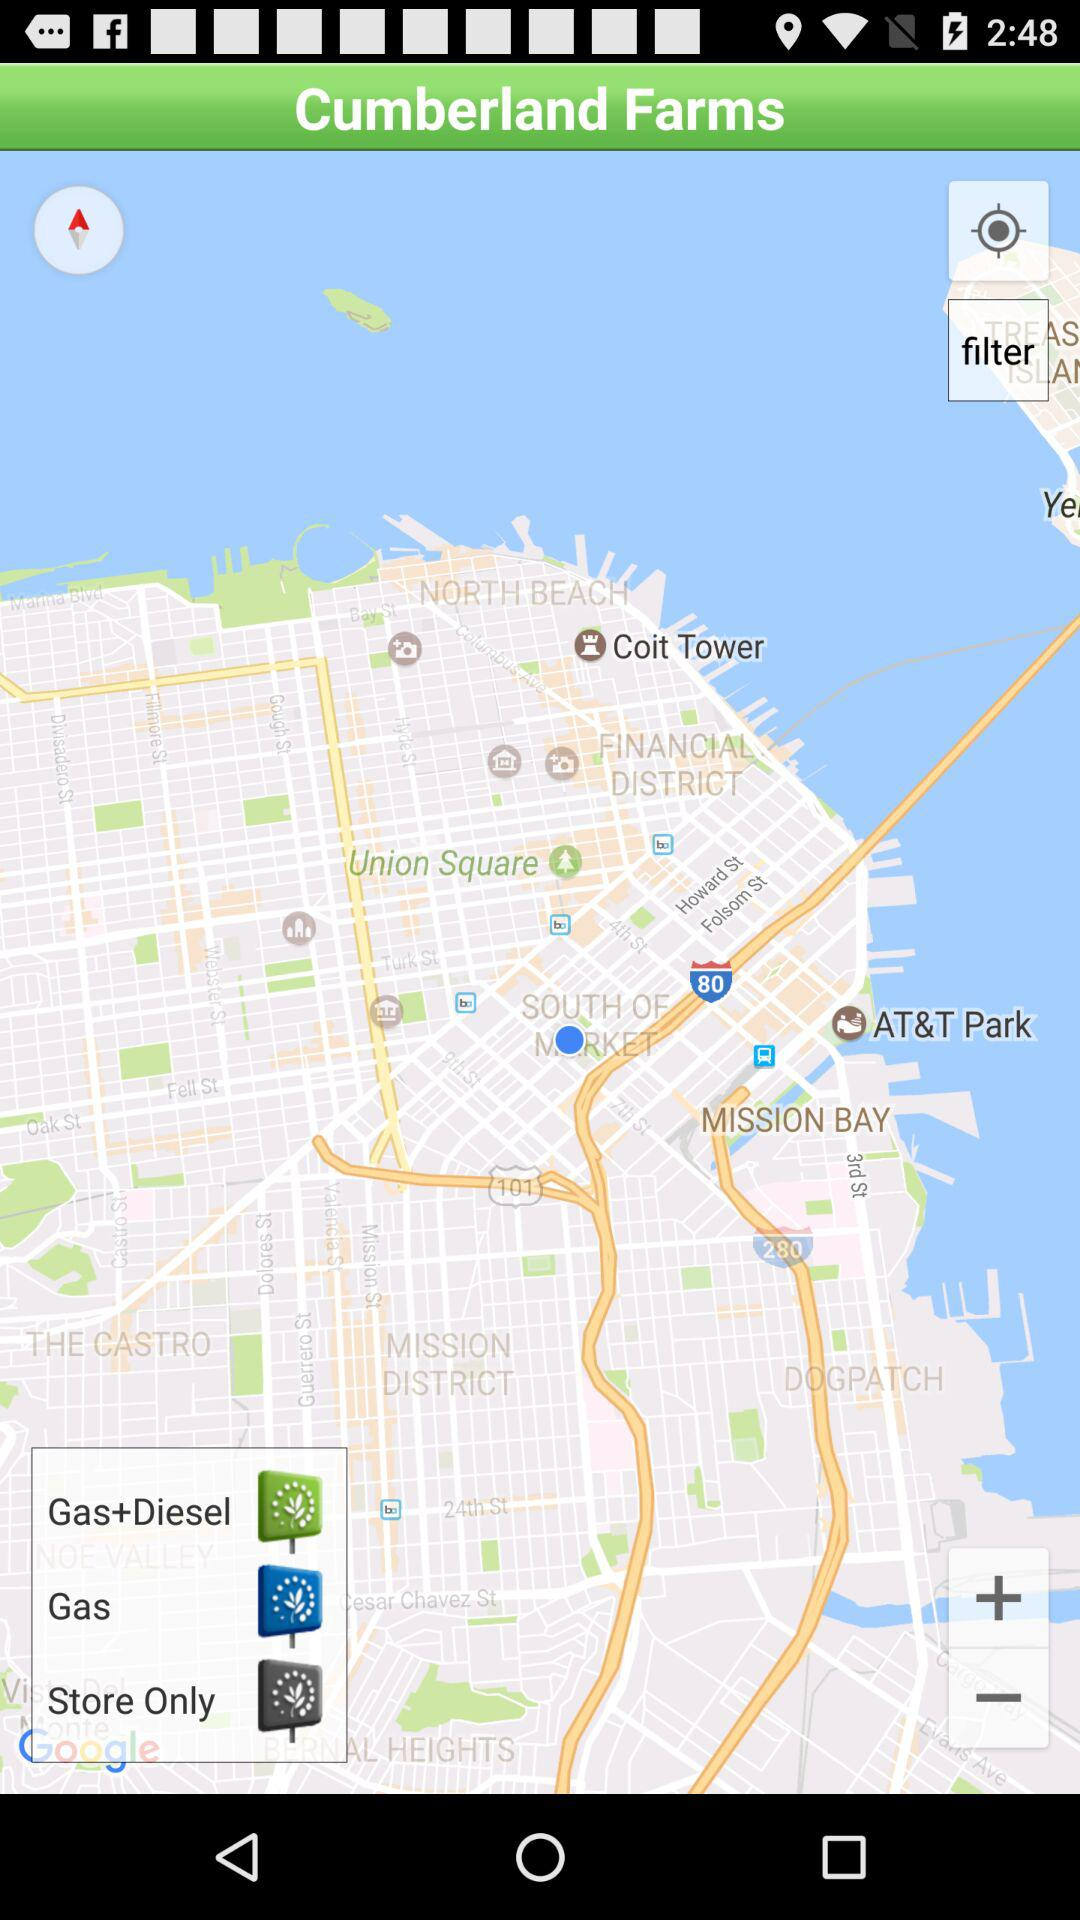How many filter options are available?
Answer the question using a single word or phrase. 3 